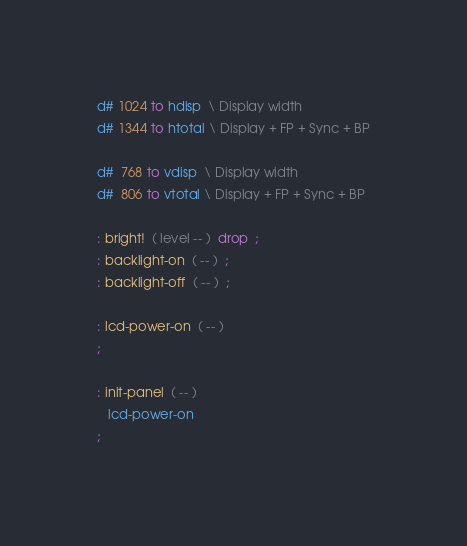Convert code to text. <code><loc_0><loc_0><loc_500><loc_500><_Forth_>d# 1024 to hdisp  \ Display width
d# 1344 to htotal \ Display + FP + Sync + BP

d#  768 to vdisp  \ Display width
d#  806 to vtotal \ Display + FP + Sync + BP

: bright!  ( level -- )  drop  ;
: backlight-on  ( -- )  ;
: backlight-off  ( -- )  ;

: lcd-power-on  ( -- )
;

: init-panel  ( -- )
   lcd-power-on
;
</code> 